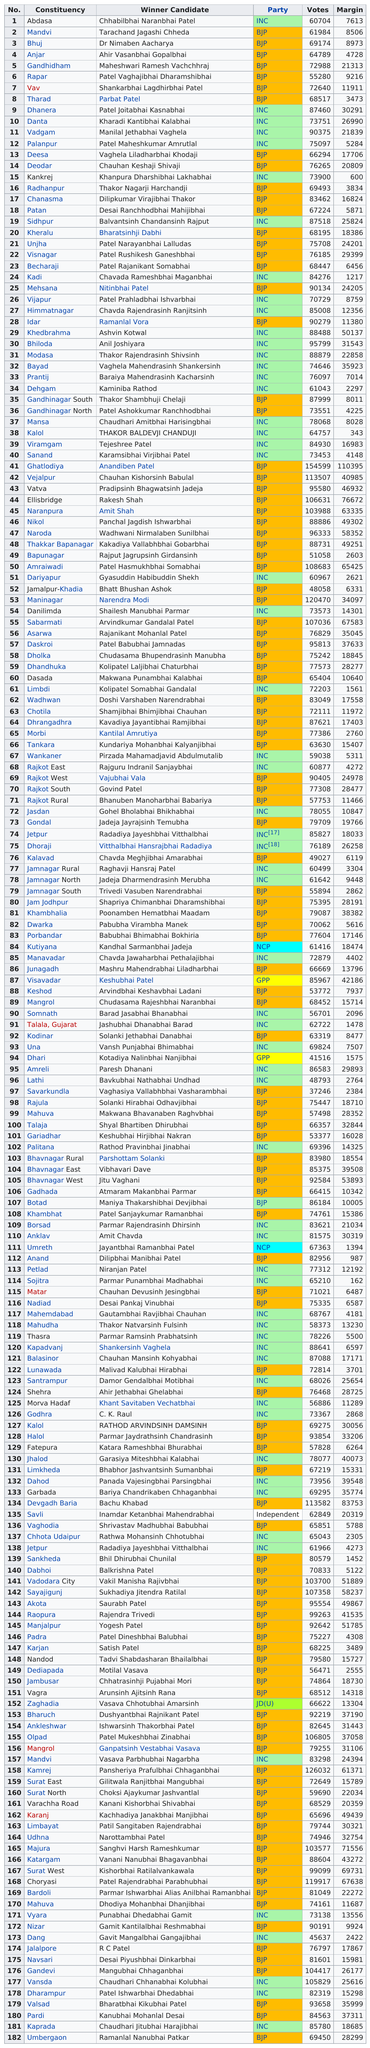Indicate a few pertinent items in this graphic. In the first election, there was a difference of 1280 votes between the two candidates. Deodar received 76,265 votes. Palanpur is located in the constituency that comes immediately before Vadgam. Abdasa's vote margin is smaller than Mandvi. Dr. Nimaben Aacharya's previous winner candidate is Tarachand Jagashi Chheda. 